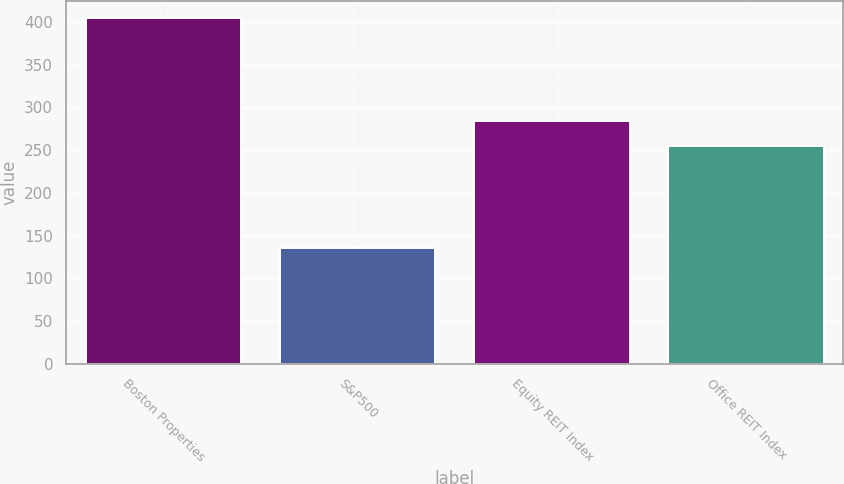Convert chart to OTSL. <chart><loc_0><loc_0><loc_500><loc_500><bar_chart><fcel>Boston Properties<fcel>S&P500<fcel>Equity REIT Index<fcel>Office REIT Index<nl><fcel>404.31<fcel>135.02<fcel>283.78<fcel>254.29<nl></chart> 